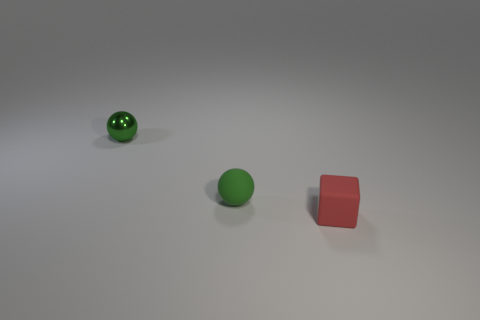Are there any green metallic balls of the same size as the green matte object?
Your answer should be compact. Yes. Is the metallic object the same color as the tiny block?
Keep it short and to the point. No. What is the color of the small object on the right side of the green ball on the right side of the tiny metal thing?
Your answer should be compact. Red. What number of small objects are both in front of the green rubber sphere and behind the rubber block?
Make the answer very short. 0. How many small red objects have the same shape as the small green metallic thing?
Your answer should be very brief. 0. What shape is the object right of the small rubber object that is on the left side of the rubber block?
Keep it short and to the point. Cube. There is a tiny matte thing that is behind the red thing; what number of small things are behind it?
Make the answer very short. 1. There is a small object that is both right of the shiny object and behind the rubber cube; what material is it?
Your answer should be very brief. Rubber. What shape is the red matte object that is the same size as the metal ball?
Give a very brief answer. Cube. There is a tiny ball on the right side of the small ball on the left side of the small matte object that is behind the red matte thing; what is its color?
Give a very brief answer. Green. 